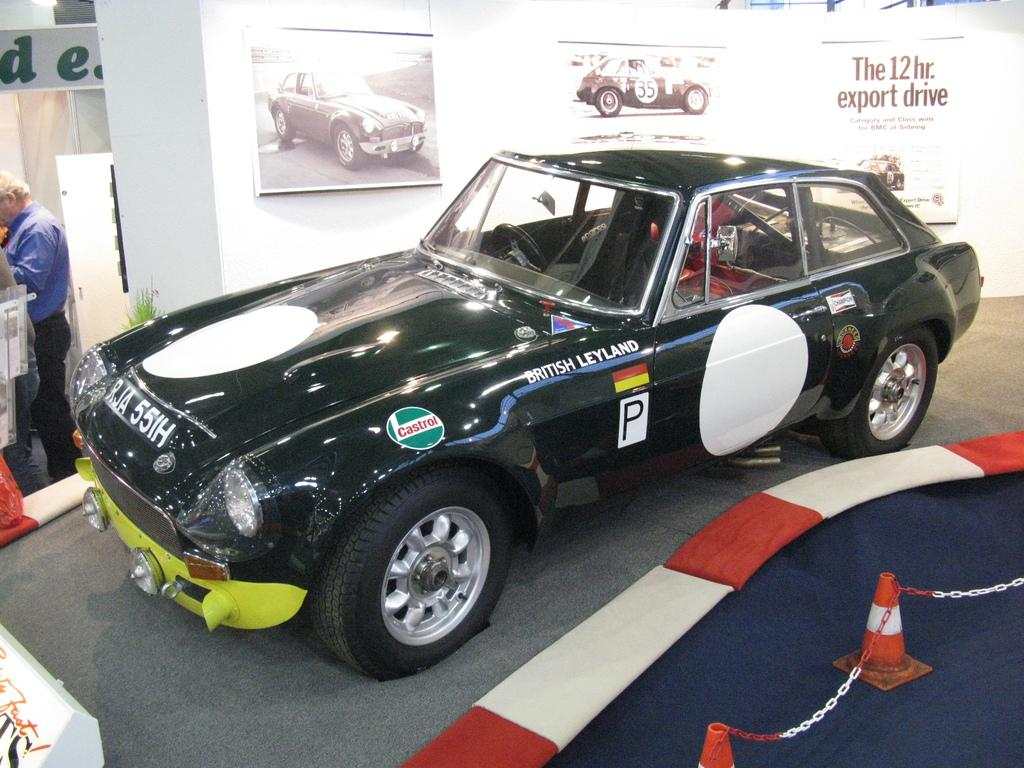What is the main subject in the center of the image? There is a car in the center of the image. Who or what is on the left side of the image? There is a man on the left side of the image. What can be seen on the wall in the background? There are boards placed on the wall in the background. What objects are present at the bottom of the image? Traffic cones are present at the bottom of the image. What type of cup is being used to commit a crime in the image? There is no cup or crime present in the image. 